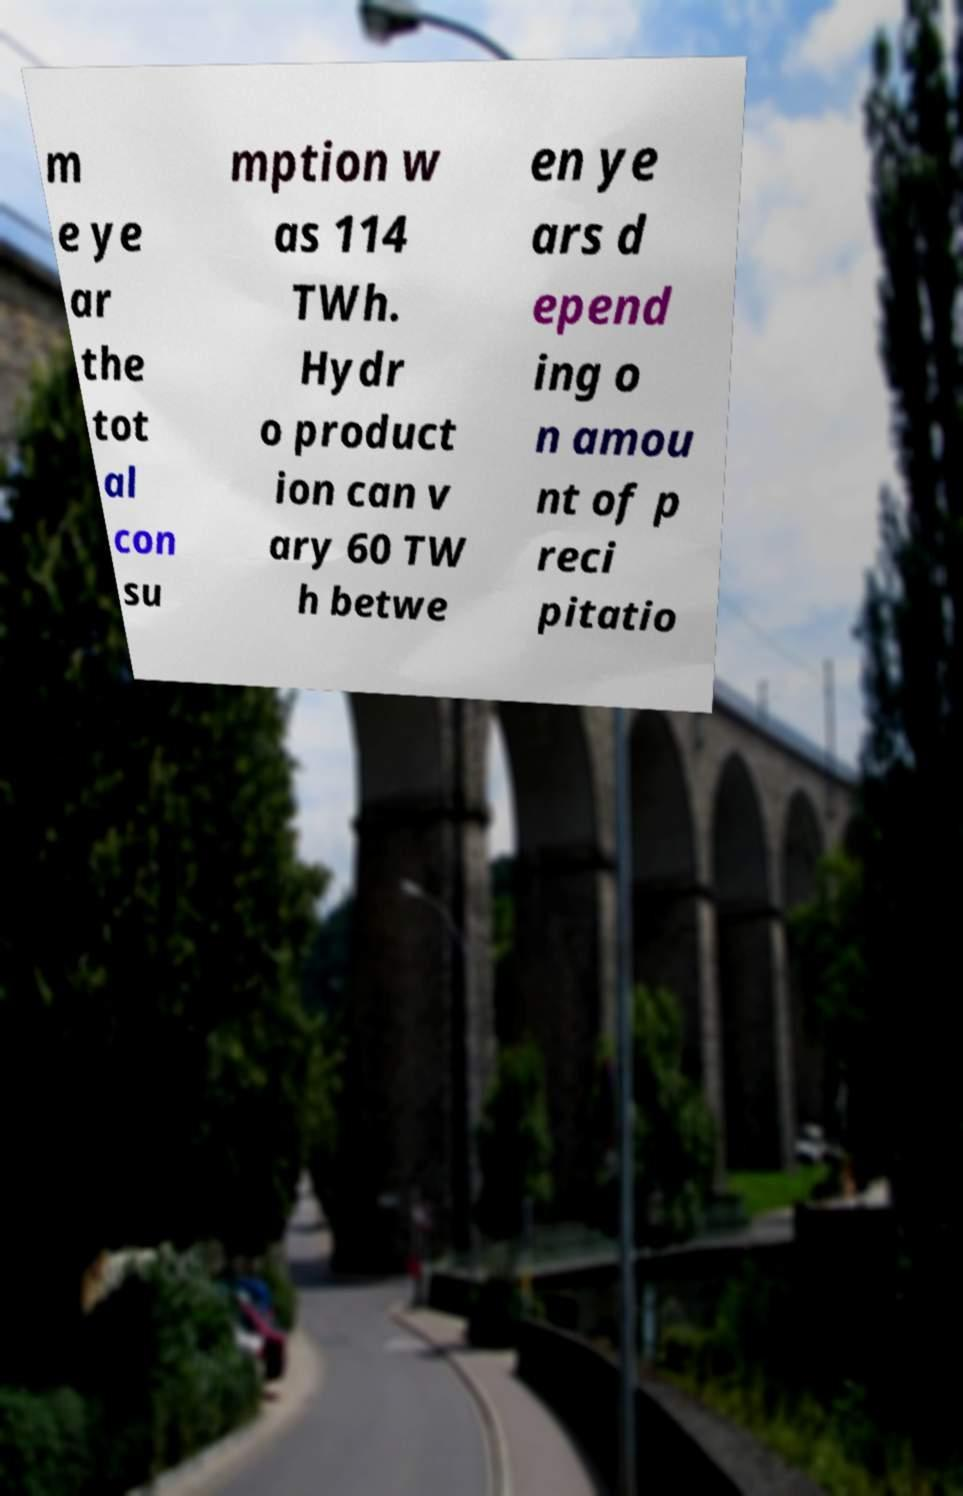Could you extract and type out the text from this image? m e ye ar the tot al con su mption w as 114 TWh. Hydr o product ion can v ary 60 TW h betwe en ye ars d epend ing o n amou nt of p reci pitatio 